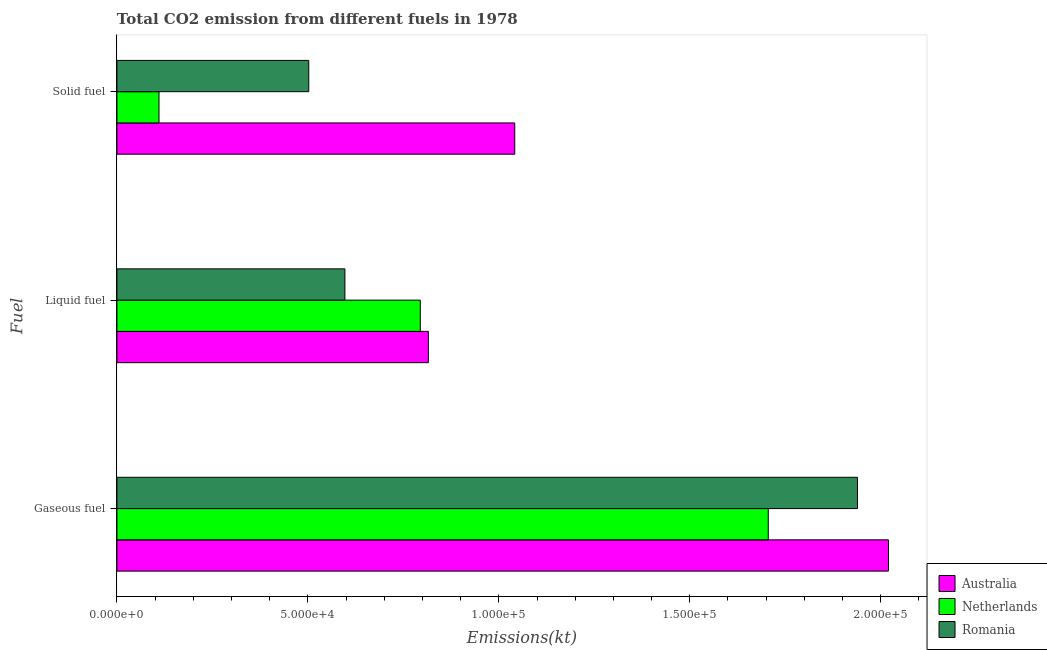How many different coloured bars are there?
Provide a short and direct response. 3. Are the number of bars per tick equal to the number of legend labels?
Offer a terse response. Yes. How many bars are there on the 3rd tick from the top?
Provide a short and direct response. 3. What is the label of the 2nd group of bars from the top?
Make the answer very short. Liquid fuel. What is the amount of co2 emissions from liquid fuel in Romania?
Your response must be concise. 5.97e+04. Across all countries, what is the maximum amount of co2 emissions from gaseous fuel?
Ensure brevity in your answer.  2.02e+05. Across all countries, what is the minimum amount of co2 emissions from solid fuel?
Your answer should be very brief. 1.10e+04. What is the total amount of co2 emissions from liquid fuel in the graph?
Keep it short and to the point. 2.21e+05. What is the difference between the amount of co2 emissions from solid fuel in Romania and that in Australia?
Your response must be concise. -5.39e+04. What is the difference between the amount of co2 emissions from solid fuel in Netherlands and the amount of co2 emissions from liquid fuel in Australia?
Your response must be concise. -7.05e+04. What is the average amount of co2 emissions from liquid fuel per country?
Provide a succinct answer. 7.36e+04. What is the difference between the amount of co2 emissions from gaseous fuel and amount of co2 emissions from liquid fuel in Australia?
Your response must be concise. 1.20e+05. In how many countries, is the amount of co2 emissions from liquid fuel greater than 170000 kt?
Your answer should be compact. 0. What is the ratio of the amount of co2 emissions from gaseous fuel in Netherlands to that in Australia?
Your response must be concise. 0.84. Is the difference between the amount of co2 emissions from gaseous fuel in Australia and Netherlands greater than the difference between the amount of co2 emissions from solid fuel in Australia and Netherlands?
Offer a very short reply. No. What is the difference between the highest and the second highest amount of co2 emissions from liquid fuel?
Ensure brevity in your answer.  2112.19. What is the difference between the highest and the lowest amount of co2 emissions from solid fuel?
Your response must be concise. 9.31e+04. What does the 1st bar from the top in Solid fuel represents?
Your answer should be compact. Romania. How many countries are there in the graph?
Provide a succinct answer. 3. What is the difference between two consecutive major ticks on the X-axis?
Offer a terse response. 5.00e+04. Are the values on the major ticks of X-axis written in scientific E-notation?
Offer a terse response. Yes. What is the title of the graph?
Offer a terse response. Total CO2 emission from different fuels in 1978. What is the label or title of the X-axis?
Offer a terse response. Emissions(kt). What is the label or title of the Y-axis?
Give a very brief answer. Fuel. What is the Emissions(kt) of Australia in Gaseous fuel?
Ensure brevity in your answer.  2.02e+05. What is the Emissions(kt) of Netherlands in Gaseous fuel?
Your answer should be compact. 1.71e+05. What is the Emissions(kt) of Romania in Gaseous fuel?
Your answer should be very brief. 1.94e+05. What is the Emissions(kt) of Australia in Liquid fuel?
Provide a succinct answer. 8.15e+04. What is the Emissions(kt) of Netherlands in Liquid fuel?
Offer a terse response. 7.94e+04. What is the Emissions(kt) in Romania in Liquid fuel?
Make the answer very short. 5.97e+04. What is the Emissions(kt) in Australia in Solid fuel?
Make the answer very short. 1.04e+05. What is the Emissions(kt) in Netherlands in Solid fuel?
Ensure brevity in your answer.  1.10e+04. What is the Emissions(kt) in Romania in Solid fuel?
Provide a succinct answer. 5.02e+04. Across all Fuel, what is the maximum Emissions(kt) of Australia?
Give a very brief answer. 2.02e+05. Across all Fuel, what is the maximum Emissions(kt) in Netherlands?
Your response must be concise. 1.71e+05. Across all Fuel, what is the maximum Emissions(kt) of Romania?
Your response must be concise. 1.94e+05. Across all Fuel, what is the minimum Emissions(kt) in Australia?
Ensure brevity in your answer.  8.15e+04. Across all Fuel, what is the minimum Emissions(kt) in Netherlands?
Ensure brevity in your answer.  1.10e+04. Across all Fuel, what is the minimum Emissions(kt) in Romania?
Keep it short and to the point. 5.02e+04. What is the total Emissions(kt) in Australia in the graph?
Your answer should be compact. 3.88e+05. What is the total Emissions(kt) of Netherlands in the graph?
Offer a very short reply. 2.61e+05. What is the total Emissions(kt) of Romania in the graph?
Your answer should be compact. 3.04e+05. What is the difference between the Emissions(kt) in Australia in Gaseous fuel and that in Liquid fuel?
Provide a short and direct response. 1.20e+05. What is the difference between the Emissions(kt) in Netherlands in Gaseous fuel and that in Liquid fuel?
Provide a succinct answer. 9.11e+04. What is the difference between the Emissions(kt) in Romania in Gaseous fuel and that in Liquid fuel?
Provide a short and direct response. 1.34e+05. What is the difference between the Emissions(kt) of Australia in Gaseous fuel and that in Solid fuel?
Your answer should be compact. 9.79e+04. What is the difference between the Emissions(kt) of Netherlands in Gaseous fuel and that in Solid fuel?
Offer a terse response. 1.60e+05. What is the difference between the Emissions(kt) of Romania in Gaseous fuel and that in Solid fuel?
Your response must be concise. 1.44e+05. What is the difference between the Emissions(kt) of Australia in Liquid fuel and that in Solid fuel?
Give a very brief answer. -2.26e+04. What is the difference between the Emissions(kt) of Netherlands in Liquid fuel and that in Solid fuel?
Ensure brevity in your answer.  6.84e+04. What is the difference between the Emissions(kt) in Romania in Liquid fuel and that in Solid fuel?
Give a very brief answer. 9460.86. What is the difference between the Emissions(kt) of Australia in Gaseous fuel and the Emissions(kt) of Netherlands in Liquid fuel?
Offer a very short reply. 1.23e+05. What is the difference between the Emissions(kt) of Australia in Gaseous fuel and the Emissions(kt) of Romania in Liquid fuel?
Ensure brevity in your answer.  1.42e+05. What is the difference between the Emissions(kt) in Netherlands in Gaseous fuel and the Emissions(kt) in Romania in Liquid fuel?
Your answer should be compact. 1.11e+05. What is the difference between the Emissions(kt) of Australia in Gaseous fuel and the Emissions(kt) of Netherlands in Solid fuel?
Offer a terse response. 1.91e+05. What is the difference between the Emissions(kt) in Australia in Gaseous fuel and the Emissions(kt) in Romania in Solid fuel?
Your answer should be compact. 1.52e+05. What is the difference between the Emissions(kt) of Netherlands in Gaseous fuel and the Emissions(kt) of Romania in Solid fuel?
Provide a short and direct response. 1.20e+05. What is the difference between the Emissions(kt) of Australia in Liquid fuel and the Emissions(kt) of Netherlands in Solid fuel?
Keep it short and to the point. 7.05e+04. What is the difference between the Emissions(kt) of Australia in Liquid fuel and the Emissions(kt) of Romania in Solid fuel?
Your answer should be compact. 3.13e+04. What is the difference between the Emissions(kt) of Netherlands in Liquid fuel and the Emissions(kt) of Romania in Solid fuel?
Your answer should be very brief. 2.92e+04. What is the average Emissions(kt) in Australia per Fuel?
Make the answer very short. 1.29e+05. What is the average Emissions(kt) of Netherlands per Fuel?
Make the answer very short. 8.70e+04. What is the average Emissions(kt) of Romania per Fuel?
Offer a very short reply. 1.01e+05. What is the difference between the Emissions(kt) in Australia and Emissions(kt) in Netherlands in Gaseous fuel?
Your answer should be very brief. 3.15e+04. What is the difference between the Emissions(kt) in Australia and Emissions(kt) in Romania in Gaseous fuel?
Keep it short and to the point. 8111.4. What is the difference between the Emissions(kt) of Netherlands and Emissions(kt) of Romania in Gaseous fuel?
Provide a short and direct response. -2.34e+04. What is the difference between the Emissions(kt) of Australia and Emissions(kt) of Netherlands in Liquid fuel?
Ensure brevity in your answer.  2112.19. What is the difference between the Emissions(kt) of Australia and Emissions(kt) of Romania in Liquid fuel?
Offer a very short reply. 2.19e+04. What is the difference between the Emissions(kt) in Netherlands and Emissions(kt) in Romania in Liquid fuel?
Offer a terse response. 1.97e+04. What is the difference between the Emissions(kt) in Australia and Emissions(kt) in Netherlands in Solid fuel?
Make the answer very short. 9.31e+04. What is the difference between the Emissions(kt) of Australia and Emissions(kt) of Romania in Solid fuel?
Ensure brevity in your answer.  5.39e+04. What is the difference between the Emissions(kt) of Netherlands and Emissions(kt) of Romania in Solid fuel?
Ensure brevity in your answer.  -3.92e+04. What is the ratio of the Emissions(kt) in Australia in Gaseous fuel to that in Liquid fuel?
Make the answer very short. 2.48. What is the ratio of the Emissions(kt) of Netherlands in Gaseous fuel to that in Liquid fuel?
Make the answer very short. 2.15. What is the ratio of the Emissions(kt) in Romania in Gaseous fuel to that in Liquid fuel?
Your answer should be compact. 3.25. What is the ratio of the Emissions(kt) of Australia in Gaseous fuel to that in Solid fuel?
Your answer should be compact. 1.94. What is the ratio of the Emissions(kt) in Netherlands in Gaseous fuel to that in Solid fuel?
Ensure brevity in your answer.  15.48. What is the ratio of the Emissions(kt) of Romania in Gaseous fuel to that in Solid fuel?
Provide a succinct answer. 3.86. What is the ratio of the Emissions(kt) of Australia in Liquid fuel to that in Solid fuel?
Your answer should be compact. 0.78. What is the ratio of the Emissions(kt) of Netherlands in Liquid fuel to that in Solid fuel?
Offer a very short reply. 7.21. What is the ratio of the Emissions(kt) of Romania in Liquid fuel to that in Solid fuel?
Provide a short and direct response. 1.19. What is the difference between the highest and the second highest Emissions(kt) in Australia?
Provide a succinct answer. 9.79e+04. What is the difference between the highest and the second highest Emissions(kt) in Netherlands?
Make the answer very short. 9.11e+04. What is the difference between the highest and the second highest Emissions(kt) of Romania?
Provide a succinct answer. 1.34e+05. What is the difference between the highest and the lowest Emissions(kt) in Australia?
Your answer should be compact. 1.20e+05. What is the difference between the highest and the lowest Emissions(kt) of Netherlands?
Your response must be concise. 1.60e+05. What is the difference between the highest and the lowest Emissions(kt) of Romania?
Provide a succinct answer. 1.44e+05. 